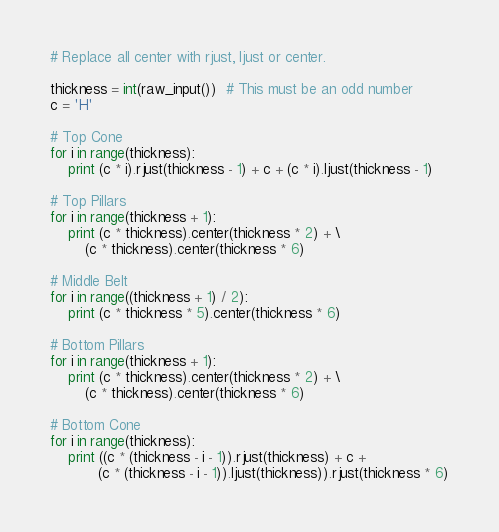Convert code to text. <code><loc_0><loc_0><loc_500><loc_500><_Python_># Replace all center with rjust, ljust or center.

thickness = int(raw_input())  # This must be an odd number
c = 'H'

# Top Cone
for i in range(thickness):
    print (c * i).rjust(thickness - 1) + c + (c * i).ljust(thickness - 1)

# Top Pillars
for i in range(thickness + 1):
    print (c * thickness).center(thickness * 2) + \
        (c * thickness).center(thickness * 6)

# Middle Belt
for i in range((thickness + 1) / 2):
    print (c * thickness * 5).center(thickness * 6)

# Bottom Pillars
for i in range(thickness + 1):
    print (c * thickness).center(thickness * 2) + \
        (c * thickness).center(thickness * 6)

# Bottom Cone
for i in range(thickness):
    print ((c * (thickness - i - 1)).rjust(thickness) + c +
           (c * (thickness - i - 1)).ljust(thickness)).rjust(thickness * 6)
</code> 